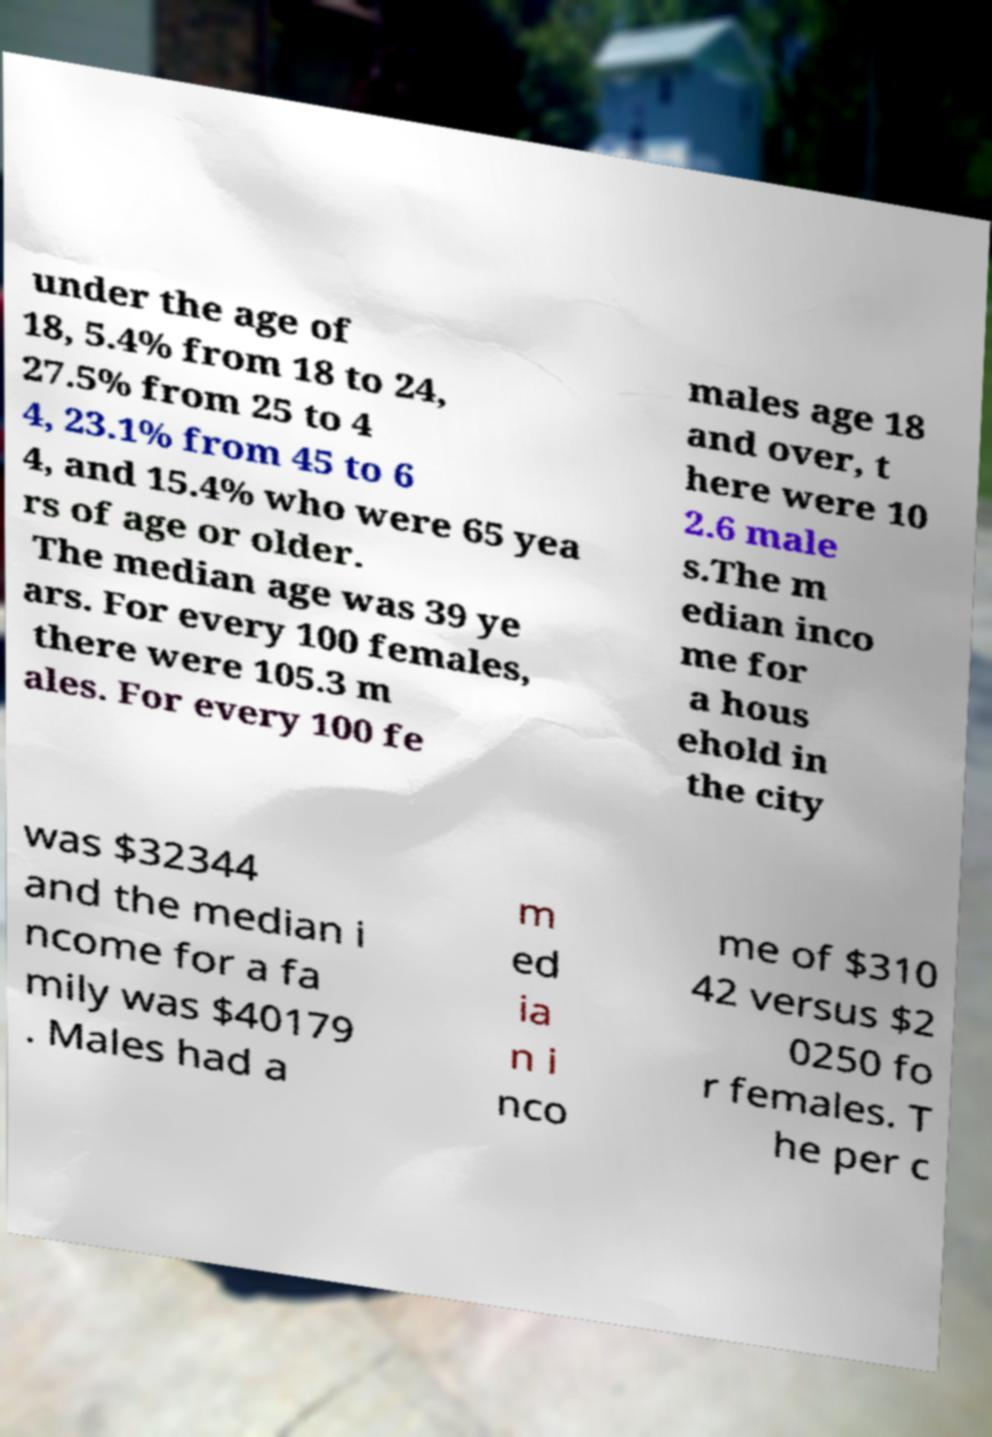Can you accurately transcribe the text from the provided image for me? under the age of 18, 5.4% from 18 to 24, 27.5% from 25 to 4 4, 23.1% from 45 to 6 4, and 15.4% who were 65 yea rs of age or older. The median age was 39 ye ars. For every 100 females, there were 105.3 m ales. For every 100 fe males age 18 and over, t here were 10 2.6 male s.The m edian inco me for a hous ehold in the city was $32344 and the median i ncome for a fa mily was $40179 . Males had a m ed ia n i nco me of $310 42 versus $2 0250 fo r females. T he per c 